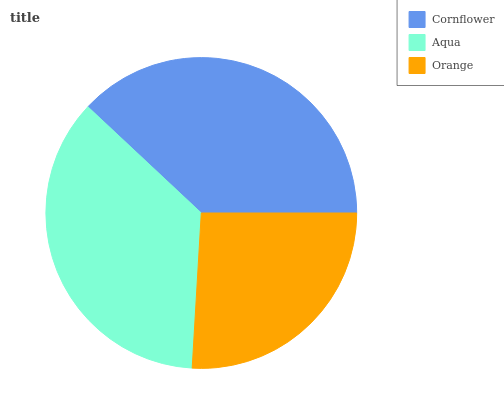Is Orange the minimum?
Answer yes or no. Yes. Is Cornflower the maximum?
Answer yes or no. Yes. Is Aqua the minimum?
Answer yes or no. No. Is Aqua the maximum?
Answer yes or no. No. Is Cornflower greater than Aqua?
Answer yes or no. Yes. Is Aqua less than Cornflower?
Answer yes or no. Yes. Is Aqua greater than Cornflower?
Answer yes or no. No. Is Cornflower less than Aqua?
Answer yes or no. No. Is Aqua the high median?
Answer yes or no. Yes. Is Aqua the low median?
Answer yes or no. Yes. Is Orange the high median?
Answer yes or no. No. Is Orange the low median?
Answer yes or no. No. 